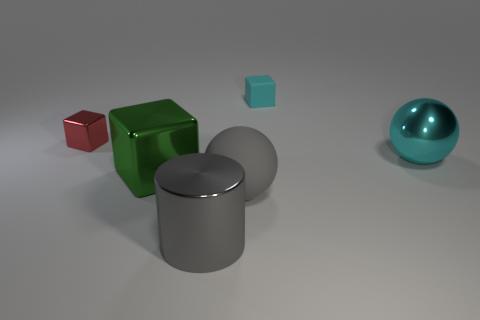Subtract all red cubes. How many cubes are left? 2 Add 2 large gray objects. How many objects exist? 8 Subtract all cyan cubes. How many cubes are left? 2 Subtract all balls. How many objects are left? 4 Subtract 1 blocks. How many blocks are left? 2 Subtract 0 brown blocks. How many objects are left? 6 Subtract all brown spheres. Subtract all blue cylinders. How many spheres are left? 2 Subtract all blocks. Subtract all cyan rubber blocks. How many objects are left? 2 Add 6 big rubber spheres. How many big rubber spheres are left? 7 Add 2 large cyan metal balls. How many large cyan metal balls exist? 3 